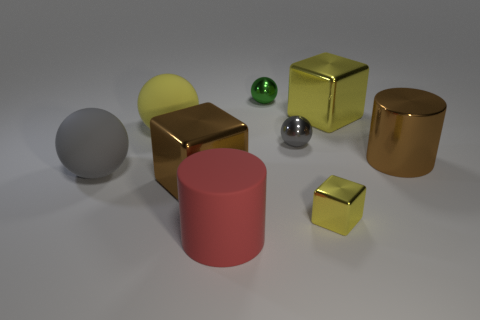Subtract all purple balls. Subtract all purple cylinders. How many balls are left? 4 Add 1 large green rubber objects. How many objects exist? 10 Subtract all balls. How many objects are left? 5 Subtract all big brown cylinders. Subtract all shiny cylinders. How many objects are left? 7 Add 9 small gray objects. How many small gray objects are left? 10 Add 1 tiny purple shiny spheres. How many tiny purple shiny spheres exist? 1 Subtract 0 red spheres. How many objects are left? 9 